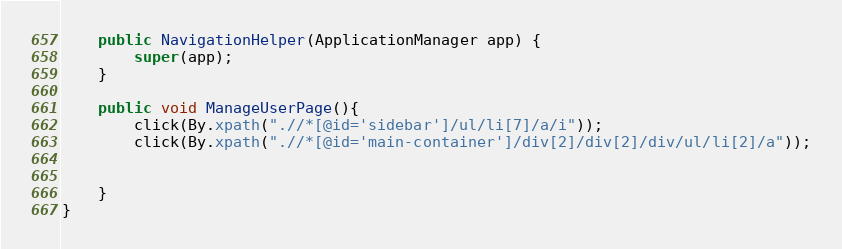Convert code to text. <code><loc_0><loc_0><loc_500><loc_500><_Java_>    public NavigationHelper(ApplicationManager app) {
        super(app);
    }

    public void ManageUserPage(){
        click(By.xpath(".//*[@id='sidebar']/ul/li[7]/a/i"));
        click(By.xpath(".//*[@id='main-container']/div[2]/div[2]/div/ul/li[2]/a"));


    }
}
</code> 